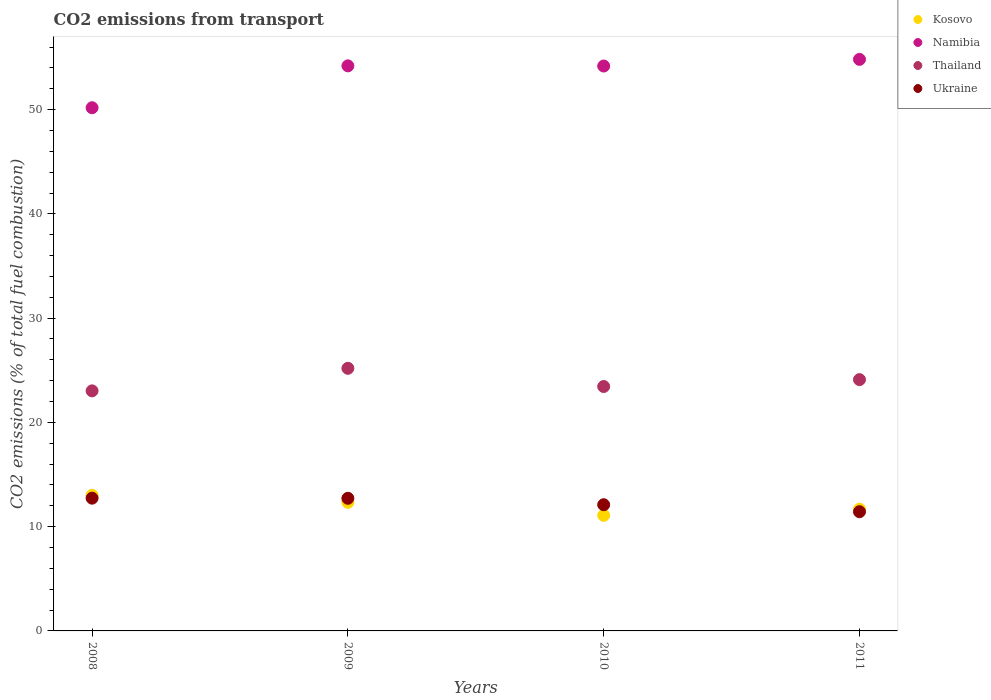What is the total CO2 emitted in Kosovo in 2008?
Your response must be concise. 13. Across all years, what is the maximum total CO2 emitted in Kosovo?
Provide a succinct answer. 13. Across all years, what is the minimum total CO2 emitted in Ukraine?
Ensure brevity in your answer.  11.43. In which year was the total CO2 emitted in Thailand maximum?
Offer a very short reply. 2009. What is the total total CO2 emitted in Thailand in the graph?
Ensure brevity in your answer.  95.75. What is the difference between the total CO2 emitted in Namibia in 2008 and that in 2011?
Your response must be concise. -4.64. What is the difference between the total CO2 emitted in Thailand in 2011 and the total CO2 emitted in Kosovo in 2008?
Give a very brief answer. 11.1. What is the average total CO2 emitted in Namibia per year?
Make the answer very short. 53.34. In the year 2009, what is the difference between the total CO2 emitted in Kosovo and total CO2 emitted in Namibia?
Give a very brief answer. -41.86. In how many years, is the total CO2 emitted in Kosovo greater than 18?
Provide a succinct answer. 0. What is the ratio of the total CO2 emitted in Kosovo in 2008 to that in 2011?
Offer a terse response. 1.11. Is the total CO2 emitted in Thailand in 2010 less than that in 2011?
Your response must be concise. Yes. What is the difference between the highest and the second highest total CO2 emitted in Namibia?
Ensure brevity in your answer.  0.62. What is the difference between the highest and the lowest total CO2 emitted in Ukraine?
Offer a terse response. 1.3. Is it the case that in every year, the sum of the total CO2 emitted in Ukraine and total CO2 emitted in Namibia  is greater than the total CO2 emitted in Kosovo?
Make the answer very short. Yes. Does the total CO2 emitted in Ukraine monotonically increase over the years?
Provide a short and direct response. No. Is the total CO2 emitted in Ukraine strictly greater than the total CO2 emitted in Namibia over the years?
Offer a terse response. No. Is the total CO2 emitted in Kosovo strictly less than the total CO2 emitted in Ukraine over the years?
Provide a succinct answer. No. How many dotlines are there?
Give a very brief answer. 4. How many years are there in the graph?
Offer a terse response. 4. Are the values on the major ticks of Y-axis written in scientific E-notation?
Provide a succinct answer. No. What is the title of the graph?
Offer a terse response. CO2 emissions from transport. What is the label or title of the Y-axis?
Keep it short and to the point. CO2 emissions (% of total fuel combustion). What is the CO2 emissions (% of total fuel combustion) of Kosovo in 2008?
Your response must be concise. 13. What is the CO2 emissions (% of total fuel combustion) of Namibia in 2008?
Your answer should be compact. 50.18. What is the CO2 emissions (% of total fuel combustion) of Thailand in 2008?
Keep it short and to the point. 23.02. What is the CO2 emissions (% of total fuel combustion) in Ukraine in 2008?
Offer a very short reply. 12.73. What is the CO2 emissions (% of total fuel combustion) in Kosovo in 2009?
Your answer should be very brief. 12.33. What is the CO2 emissions (% of total fuel combustion) of Namibia in 2009?
Keep it short and to the point. 54.2. What is the CO2 emissions (% of total fuel combustion) in Thailand in 2009?
Give a very brief answer. 25.19. What is the CO2 emissions (% of total fuel combustion) in Ukraine in 2009?
Offer a terse response. 12.72. What is the CO2 emissions (% of total fuel combustion) of Kosovo in 2010?
Provide a succinct answer. 11.09. What is the CO2 emissions (% of total fuel combustion) of Namibia in 2010?
Your answer should be compact. 54.18. What is the CO2 emissions (% of total fuel combustion) of Thailand in 2010?
Provide a succinct answer. 23.44. What is the CO2 emissions (% of total fuel combustion) in Ukraine in 2010?
Your response must be concise. 12.1. What is the CO2 emissions (% of total fuel combustion) of Kosovo in 2011?
Make the answer very short. 11.67. What is the CO2 emissions (% of total fuel combustion) in Namibia in 2011?
Provide a succinct answer. 54.82. What is the CO2 emissions (% of total fuel combustion) of Thailand in 2011?
Keep it short and to the point. 24.1. What is the CO2 emissions (% of total fuel combustion) of Ukraine in 2011?
Offer a very short reply. 11.43. Across all years, what is the maximum CO2 emissions (% of total fuel combustion) in Kosovo?
Keep it short and to the point. 13. Across all years, what is the maximum CO2 emissions (% of total fuel combustion) in Namibia?
Keep it short and to the point. 54.82. Across all years, what is the maximum CO2 emissions (% of total fuel combustion) in Thailand?
Provide a succinct answer. 25.19. Across all years, what is the maximum CO2 emissions (% of total fuel combustion) in Ukraine?
Provide a succinct answer. 12.73. Across all years, what is the minimum CO2 emissions (% of total fuel combustion) in Kosovo?
Keep it short and to the point. 11.09. Across all years, what is the minimum CO2 emissions (% of total fuel combustion) of Namibia?
Provide a succinct answer. 50.18. Across all years, what is the minimum CO2 emissions (% of total fuel combustion) in Thailand?
Give a very brief answer. 23.02. Across all years, what is the minimum CO2 emissions (% of total fuel combustion) in Ukraine?
Make the answer very short. 11.43. What is the total CO2 emissions (% of total fuel combustion) of Kosovo in the graph?
Ensure brevity in your answer.  48.1. What is the total CO2 emissions (% of total fuel combustion) in Namibia in the graph?
Provide a succinct answer. 213.37. What is the total CO2 emissions (% of total fuel combustion) in Thailand in the graph?
Provide a short and direct response. 95.75. What is the total CO2 emissions (% of total fuel combustion) in Ukraine in the graph?
Your response must be concise. 48.99. What is the difference between the CO2 emissions (% of total fuel combustion) of Kosovo in 2008 and that in 2009?
Your answer should be compact. 0.67. What is the difference between the CO2 emissions (% of total fuel combustion) of Namibia in 2008 and that in 2009?
Offer a very short reply. -4.02. What is the difference between the CO2 emissions (% of total fuel combustion) in Thailand in 2008 and that in 2009?
Ensure brevity in your answer.  -2.16. What is the difference between the CO2 emissions (% of total fuel combustion) in Ukraine in 2008 and that in 2009?
Provide a short and direct response. 0.01. What is the difference between the CO2 emissions (% of total fuel combustion) of Kosovo in 2008 and that in 2010?
Offer a terse response. 1.92. What is the difference between the CO2 emissions (% of total fuel combustion) in Namibia in 2008 and that in 2010?
Your answer should be very brief. -4. What is the difference between the CO2 emissions (% of total fuel combustion) in Thailand in 2008 and that in 2010?
Your answer should be compact. -0.42. What is the difference between the CO2 emissions (% of total fuel combustion) in Ukraine in 2008 and that in 2010?
Provide a short and direct response. 0.63. What is the difference between the CO2 emissions (% of total fuel combustion) of Kosovo in 2008 and that in 2011?
Your response must be concise. 1.33. What is the difference between the CO2 emissions (% of total fuel combustion) of Namibia in 2008 and that in 2011?
Make the answer very short. -4.64. What is the difference between the CO2 emissions (% of total fuel combustion) of Thailand in 2008 and that in 2011?
Offer a very short reply. -1.08. What is the difference between the CO2 emissions (% of total fuel combustion) of Ukraine in 2008 and that in 2011?
Offer a terse response. 1.3. What is the difference between the CO2 emissions (% of total fuel combustion) of Kosovo in 2009 and that in 2010?
Your answer should be compact. 1.25. What is the difference between the CO2 emissions (% of total fuel combustion) of Namibia in 2009 and that in 2010?
Give a very brief answer. 0.02. What is the difference between the CO2 emissions (% of total fuel combustion) in Thailand in 2009 and that in 2010?
Provide a succinct answer. 1.75. What is the difference between the CO2 emissions (% of total fuel combustion) of Ukraine in 2009 and that in 2010?
Ensure brevity in your answer.  0.62. What is the difference between the CO2 emissions (% of total fuel combustion) of Kosovo in 2009 and that in 2011?
Make the answer very short. 0.66. What is the difference between the CO2 emissions (% of total fuel combustion) in Namibia in 2009 and that in 2011?
Make the answer very short. -0.62. What is the difference between the CO2 emissions (% of total fuel combustion) in Thailand in 2009 and that in 2011?
Ensure brevity in your answer.  1.09. What is the difference between the CO2 emissions (% of total fuel combustion) in Ukraine in 2009 and that in 2011?
Provide a short and direct response. 1.29. What is the difference between the CO2 emissions (% of total fuel combustion) of Kosovo in 2010 and that in 2011?
Your response must be concise. -0.59. What is the difference between the CO2 emissions (% of total fuel combustion) of Namibia in 2010 and that in 2011?
Keep it short and to the point. -0.64. What is the difference between the CO2 emissions (% of total fuel combustion) in Thailand in 2010 and that in 2011?
Ensure brevity in your answer.  -0.66. What is the difference between the CO2 emissions (% of total fuel combustion) of Ukraine in 2010 and that in 2011?
Your response must be concise. 0.67. What is the difference between the CO2 emissions (% of total fuel combustion) in Kosovo in 2008 and the CO2 emissions (% of total fuel combustion) in Namibia in 2009?
Ensure brevity in your answer.  -41.19. What is the difference between the CO2 emissions (% of total fuel combustion) of Kosovo in 2008 and the CO2 emissions (% of total fuel combustion) of Thailand in 2009?
Your answer should be compact. -12.18. What is the difference between the CO2 emissions (% of total fuel combustion) in Kosovo in 2008 and the CO2 emissions (% of total fuel combustion) in Ukraine in 2009?
Provide a succinct answer. 0.28. What is the difference between the CO2 emissions (% of total fuel combustion) in Namibia in 2008 and the CO2 emissions (% of total fuel combustion) in Thailand in 2009?
Your response must be concise. 24.99. What is the difference between the CO2 emissions (% of total fuel combustion) of Namibia in 2008 and the CO2 emissions (% of total fuel combustion) of Ukraine in 2009?
Provide a short and direct response. 37.46. What is the difference between the CO2 emissions (% of total fuel combustion) in Thailand in 2008 and the CO2 emissions (% of total fuel combustion) in Ukraine in 2009?
Keep it short and to the point. 10.3. What is the difference between the CO2 emissions (% of total fuel combustion) of Kosovo in 2008 and the CO2 emissions (% of total fuel combustion) of Namibia in 2010?
Ensure brevity in your answer.  -41.18. What is the difference between the CO2 emissions (% of total fuel combustion) of Kosovo in 2008 and the CO2 emissions (% of total fuel combustion) of Thailand in 2010?
Keep it short and to the point. -10.44. What is the difference between the CO2 emissions (% of total fuel combustion) of Kosovo in 2008 and the CO2 emissions (% of total fuel combustion) of Ukraine in 2010?
Provide a succinct answer. 0.9. What is the difference between the CO2 emissions (% of total fuel combustion) in Namibia in 2008 and the CO2 emissions (% of total fuel combustion) in Thailand in 2010?
Provide a short and direct response. 26.74. What is the difference between the CO2 emissions (% of total fuel combustion) in Namibia in 2008 and the CO2 emissions (% of total fuel combustion) in Ukraine in 2010?
Your answer should be very brief. 38.08. What is the difference between the CO2 emissions (% of total fuel combustion) of Thailand in 2008 and the CO2 emissions (% of total fuel combustion) of Ukraine in 2010?
Your response must be concise. 10.92. What is the difference between the CO2 emissions (% of total fuel combustion) of Kosovo in 2008 and the CO2 emissions (% of total fuel combustion) of Namibia in 2011?
Offer a very short reply. -41.81. What is the difference between the CO2 emissions (% of total fuel combustion) of Kosovo in 2008 and the CO2 emissions (% of total fuel combustion) of Thailand in 2011?
Keep it short and to the point. -11.1. What is the difference between the CO2 emissions (% of total fuel combustion) of Kosovo in 2008 and the CO2 emissions (% of total fuel combustion) of Ukraine in 2011?
Provide a succinct answer. 1.57. What is the difference between the CO2 emissions (% of total fuel combustion) in Namibia in 2008 and the CO2 emissions (% of total fuel combustion) in Thailand in 2011?
Give a very brief answer. 26.08. What is the difference between the CO2 emissions (% of total fuel combustion) of Namibia in 2008 and the CO2 emissions (% of total fuel combustion) of Ukraine in 2011?
Offer a very short reply. 38.75. What is the difference between the CO2 emissions (% of total fuel combustion) of Thailand in 2008 and the CO2 emissions (% of total fuel combustion) of Ukraine in 2011?
Give a very brief answer. 11.59. What is the difference between the CO2 emissions (% of total fuel combustion) in Kosovo in 2009 and the CO2 emissions (% of total fuel combustion) in Namibia in 2010?
Give a very brief answer. -41.85. What is the difference between the CO2 emissions (% of total fuel combustion) in Kosovo in 2009 and the CO2 emissions (% of total fuel combustion) in Thailand in 2010?
Ensure brevity in your answer.  -11.11. What is the difference between the CO2 emissions (% of total fuel combustion) of Kosovo in 2009 and the CO2 emissions (% of total fuel combustion) of Ukraine in 2010?
Provide a succinct answer. 0.23. What is the difference between the CO2 emissions (% of total fuel combustion) of Namibia in 2009 and the CO2 emissions (% of total fuel combustion) of Thailand in 2010?
Give a very brief answer. 30.76. What is the difference between the CO2 emissions (% of total fuel combustion) of Namibia in 2009 and the CO2 emissions (% of total fuel combustion) of Ukraine in 2010?
Keep it short and to the point. 42.09. What is the difference between the CO2 emissions (% of total fuel combustion) in Thailand in 2009 and the CO2 emissions (% of total fuel combustion) in Ukraine in 2010?
Your response must be concise. 13.08. What is the difference between the CO2 emissions (% of total fuel combustion) of Kosovo in 2009 and the CO2 emissions (% of total fuel combustion) of Namibia in 2011?
Offer a very short reply. -42.48. What is the difference between the CO2 emissions (% of total fuel combustion) in Kosovo in 2009 and the CO2 emissions (% of total fuel combustion) in Thailand in 2011?
Provide a succinct answer. -11.77. What is the difference between the CO2 emissions (% of total fuel combustion) of Kosovo in 2009 and the CO2 emissions (% of total fuel combustion) of Ukraine in 2011?
Provide a succinct answer. 0.9. What is the difference between the CO2 emissions (% of total fuel combustion) in Namibia in 2009 and the CO2 emissions (% of total fuel combustion) in Thailand in 2011?
Provide a succinct answer. 30.09. What is the difference between the CO2 emissions (% of total fuel combustion) in Namibia in 2009 and the CO2 emissions (% of total fuel combustion) in Ukraine in 2011?
Keep it short and to the point. 42.76. What is the difference between the CO2 emissions (% of total fuel combustion) in Thailand in 2009 and the CO2 emissions (% of total fuel combustion) in Ukraine in 2011?
Keep it short and to the point. 13.75. What is the difference between the CO2 emissions (% of total fuel combustion) of Kosovo in 2010 and the CO2 emissions (% of total fuel combustion) of Namibia in 2011?
Provide a succinct answer. -43.73. What is the difference between the CO2 emissions (% of total fuel combustion) in Kosovo in 2010 and the CO2 emissions (% of total fuel combustion) in Thailand in 2011?
Give a very brief answer. -13.02. What is the difference between the CO2 emissions (% of total fuel combustion) in Kosovo in 2010 and the CO2 emissions (% of total fuel combustion) in Ukraine in 2011?
Your response must be concise. -0.35. What is the difference between the CO2 emissions (% of total fuel combustion) of Namibia in 2010 and the CO2 emissions (% of total fuel combustion) of Thailand in 2011?
Your answer should be compact. 30.08. What is the difference between the CO2 emissions (% of total fuel combustion) in Namibia in 2010 and the CO2 emissions (% of total fuel combustion) in Ukraine in 2011?
Keep it short and to the point. 42.75. What is the difference between the CO2 emissions (% of total fuel combustion) of Thailand in 2010 and the CO2 emissions (% of total fuel combustion) of Ukraine in 2011?
Provide a short and direct response. 12.01. What is the average CO2 emissions (% of total fuel combustion) of Kosovo per year?
Make the answer very short. 12.02. What is the average CO2 emissions (% of total fuel combustion) of Namibia per year?
Make the answer very short. 53.34. What is the average CO2 emissions (% of total fuel combustion) of Thailand per year?
Keep it short and to the point. 23.94. What is the average CO2 emissions (% of total fuel combustion) of Ukraine per year?
Keep it short and to the point. 12.25. In the year 2008, what is the difference between the CO2 emissions (% of total fuel combustion) in Kosovo and CO2 emissions (% of total fuel combustion) in Namibia?
Your response must be concise. -37.18. In the year 2008, what is the difference between the CO2 emissions (% of total fuel combustion) in Kosovo and CO2 emissions (% of total fuel combustion) in Thailand?
Give a very brief answer. -10.02. In the year 2008, what is the difference between the CO2 emissions (% of total fuel combustion) of Kosovo and CO2 emissions (% of total fuel combustion) of Ukraine?
Your answer should be very brief. 0.27. In the year 2008, what is the difference between the CO2 emissions (% of total fuel combustion) of Namibia and CO2 emissions (% of total fuel combustion) of Thailand?
Your response must be concise. 27.16. In the year 2008, what is the difference between the CO2 emissions (% of total fuel combustion) in Namibia and CO2 emissions (% of total fuel combustion) in Ukraine?
Provide a succinct answer. 37.45. In the year 2008, what is the difference between the CO2 emissions (% of total fuel combustion) of Thailand and CO2 emissions (% of total fuel combustion) of Ukraine?
Your answer should be very brief. 10.29. In the year 2009, what is the difference between the CO2 emissions (% of total fuel combustion) of Kosovo and CO2 emissions (% of total fuel combustion) of Namibia?
Keep it short and to the point. -41.86. In the year 2009, what is the difference between the CO2 emissions (% of total fuel combustion) of Kosovo and CO2 emissions (% of total fuel combustion) of Thailand?
Offer a terse response. -12.85. In the year 2009, what is the difference between the CO2 emissions (% of total fuel combustion) of Kosovo and CO2 emissions (% of total fuel combustion) of Ukraine?
Your answer should be compact. -0.39. In the year 2009, what is the difference between the CO2 emissions (% of total fuel combustion) in Namibia and CO2 emissions (% of total fuel combustion) in Thailand?
Ensure brevity in your answer.  29.01. In the year 2009, what is the difference between the CO2 emissions (% of total fuel combustion) in Namibia and CO2 emissions (% of total fuel combustion) in Ukraine?
Keep it short and to the point. 41.48. In the year 2009, what is the difference between the CO2 emissions (% of total fuel combustion) of Thailand and CO2 emissions (% of total fuel combustion) of Ukraine?
Offer a terse response. 12.47. In the year 2010, what is the difference between the CO2 emissions (% of total fuel combustion) of Kosovo and CO2 emissions (% of total fuel combustion) of Namibia?
Ensure brevity in your answer.  -43.1. In the year 2010, what is the difference between the CO2 emissions (% of total fuel combustion) of Kosovo and CO2 emissions (% of total fuel combustion) of Thailand?
Ensure brevity in your answer.  -12.36. In the year 2010, what is the difference between the CO2 emissions (% of total fuel combustion) of Kosovo and CO2 emissions (% of total fuel combustion) of Ukraine?
Offer a very short reply. -1.02. In the year 2010, what is the difference between the CO2 emissions (% of total fuel combustion) of Namibia and CO2 emissions (% of total fuel combustion) of Thailand?
Give a very brief answer. 30.74. In the year 2010, what is the difference between the CO2 emissions (% of total fuel combustion) of Namibia and CO2 emissions (% of total fuel combustion) of Ukraine?
Ensure brevity in your answer.  42.08. In the year 2010, what is the difference between the CO2 emissions (% of total fuel combustion) of Thailand and CO2 emissions (% of total fuel combustion) of Ukraine?
Keep it short and to the point. 11.34. In the year 2011, what is the difference between the CO2 emissions (% of total fuel combustion) of Kosovo and CO2 emissions (% of total fuel combustion) of Namibia?
Your answer should be compact. -43.14. In the year 2011, what is the difference between the CO2 emissions (% of total fuel combustion) of Kosovo and CO2 emissions (% of total fuel combustion) of Thailand?
Your answer should be very brief. -12.43. In the year 2011, what is the difference between the CO2 emissions (% of total fuel combustion) of Kosovo and CO2 emissions (% of total fuel combustion) of Ukraine?
Your answer should be compact. 0.24. In the year 2011, what is the difference between the CO2 emissions (% of total fuel combustion) in Namibia and CO2 emissions (% of total fuel combustion) in Thailand?
Offer a terse response. 30.72. In the year 2011, what is the difference between the CO2 emissions (% of total fuel combustion) of Namibia and CO2 emissions (% of total fuel combustion) of Ukraine?
Your answer should be compact. 43.38. In the year 2011, what is the difference between the CO2 emissions (% of total fuel combustion) in Thailand and CO2 emissions (% of total fuel combustion) in Ukraine?
Provide a short and direct response. 12.67. What is the ratio of the CO2 emissions (% of total fuel combustion) of Kosovo in 2008 to that in 2009?
Provide a short and direct response. 1.05. What is the ratio of the CO2 emissions (% of total fuel combustion) in Namibia in 2008 to that in 2009?
Offer a terse response. 0.93. What is the ratio of the CO2 emissions (% of total fuel combustion) of Thailand in 2008 to that in 2009?
Ensure brevity in your answer.  0.91. What is the ratio of the CO2 emissions (% of total fuel combustion) in Ukraine in 2008 to that in 2009?
Offer a very short reply. 1. What is the ratio of the CO2 emissions (% of total fuel combustion) in Kosovo in 2008 to that in 2010?
Ensure brevity in your answer.  1.17. What is the ratio of the CO2 emissions (% of total fuel combustion) of Namibia in 2008 to that in 2010?
Offer a very short reply. 0.93. What is the ratio of the CO2 emissions (% of total fuel combustion) of Thailand in 2008 to that in 2010?
Your response must be concise. 0.98. What is the ratio of the CO2 emissions (% of total fuel combustion) in Ukraine in 2008 to that in 2010?
Your response must be concise. 1.05. What is the ratio of the CO2 emissions (% of total fuel combustion) of Kosovo in 2008 to that in 2011?
Keep it short and to the point. 1.11. What is the ratio of the CO2 emissions (% of total fuel combustion) of Namibia in 2008 to that in 2011?
Give a very brief answer. 0.92. What is the ratio of the CO2 emissions (% of total fuel combustion) in Thailand in 2008 to that in 2011?
Your answer should be compact. 0.96. What is the ratio of the CO2 emissions (% of total fuel combustion) of Ukraine in 2008 to that in 2011?
Offer a very short reply. 1.11. What is the ratio of the CO2 emissions (% of total fuel combustion) of Kosovo in 2009 to that in 2010?
Keep it short and to the point. 1.11. What is the ratio of the CO2 emissions (% of total fuel combustion) in Namibia in 2009 to that in 2010?
Offer a very short reply. 1. What is the ratio of the CO2 emissions (% of total fuel combustion) of Thailand in 2009 to that in 2010?
Make the answer very short. 1.07. What is the ratio of the CO2 emissions (% of total fuel combustion) in Ukraine in 2009 to that in 2010?
Keep it short and to the point. 1.05. What is the ratio of the CO2 emissions (% of total fuel combustion) of Kosovo in 2009 to that in 2011?
Your answer should be very brief. 1.06. What is the ratio of the CO2 emissions (% of total fuel combustion) of Namibia in 2009 to that in 2011?
Ensure brevity in your answer.  0.99. What is the ratio of the CO2 emissions (% of total fuel combustion) of Thailand in 2009 to that in 2011?
Give a very brief answer. 1.04. What is the ratio of the CO2 emissions (% of total fuel combustion) of Ukraine in 2009 to that in 2011?
Make the answer very short. 1.11. What is the ratio of the CO2 emissions (% of total fuel combustion) of Kosovo in 2010 to that in 2011?
Provide a succinct answer. 0.95. What is the ratio of the CO2 emissions (% of total fuel combustion) of Namibia in 2010 to that in 2011?
Make the answer very short. 0.99. What is the ratio of the CO2 emissions (% of total fuel combustion) in Thailand in 2010 to that in 2011?
Provide a succinct answer. 0.97. What is the ratio of the CO2 emissions (% of total fuel combustion) in Ukraine in 2010 to that in 2011?
Your response must be concise. 1.06. What is the difference between the highest and the second highest CO2 emissions (% of total fuel combustion) of Kosovo?
Your answer should be very brief. 0.67. What is the difference between the highest and the second highest CO2 emissions (% of total fuel combustion) of Namibia?
Make the answer very short. 0.62. What is the difference between the highest and the second highest CO2 emissions (% of total fuel combustion) in Thailand?
Provide a succinct answer. 1.09. What is the difference between the highest and the second highest CO2 emissions (% of total fuel combustion) of Ukraine?
Offer a terse response. 0.01. What is the difference between the highest and the lowest CO2 emissions (% of total fuel combustion) in Kosovo?
Give a very brief answer. 1.92. What is the difference between the highest and the lowest CO2 emissions (% of total fuel combustion) of Namibia?
Offer a very short reply. 4.64. What is the difference between the highest and the lowest CO2 emissions (% of total fuel combustion) of Thailand?
Provide a succinct answer. 2.16. What is the difference between the highest and the lowest CO2 emissions (% of total fuel combustion) of Ukraine?
Your answer should be compact. 1.3. 